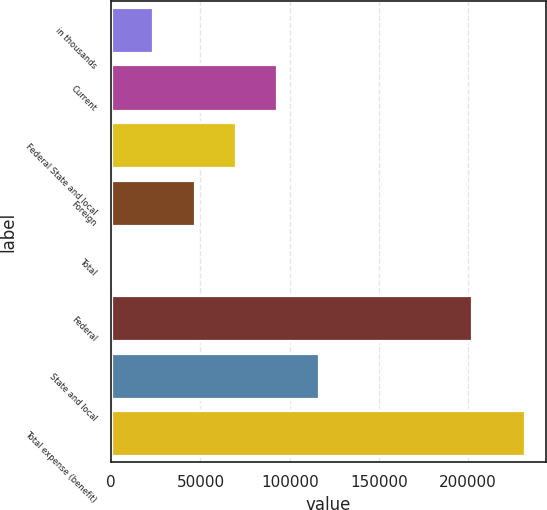<chart> <loc_0><loc_0><loc_500><loc_500><bar_chart><fcel>in thousands<fcel>Current<fcel>Federal State and local<fcel>Foreign<fcel>Total<fcel>Federal<fcel>State and local<fcel>Total expense (benefit)<nl><fcel>23526.1<fcel>93042.4<fcel>69870.3<fcel>46698.2<fcel>354<fcel>202184<fcel>116214<fcel>232075<nl></chart> 